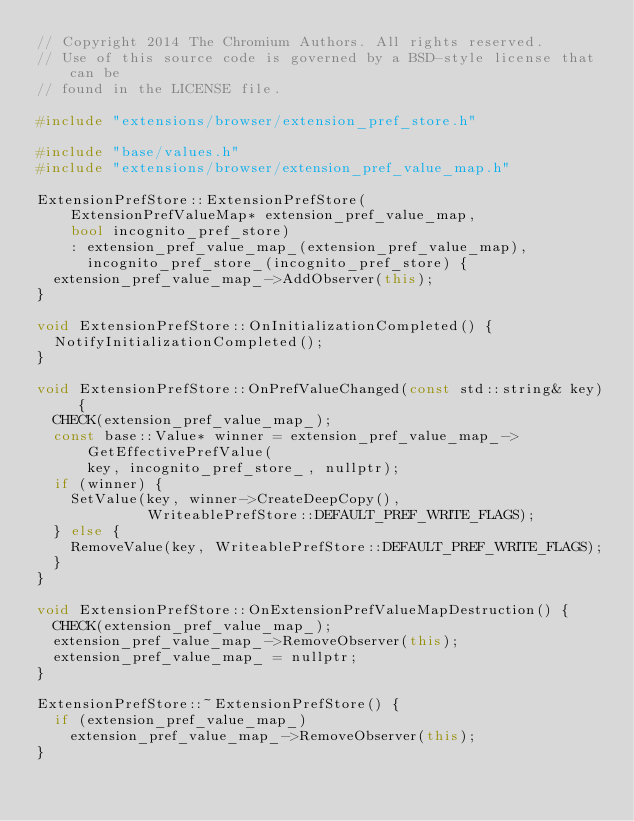<code> <loc_0><loc_0><loc_500><loc_500><_C++_>// Copyright 2014 The Chromium Authors. All rights reserved.
// Use of this source code is governed by a BSD-style license that can be
// found in the LICENSE file.

#include "extensions/browser/extension_pref_store.h"

#include "base/values.h"
#include "extensions/browser/extension_pref_value_map.h"

ExtensionPrefStore::ExtensionPrefStore(
    ExtensionPrefValueMap* extension_pref_value_map,
    bool incognito_pref_store)
    : extension_pref_value_map_(extension_pref_value_map),
      incognito_pref_store_(incognito_pref_store) {
  extension_pref_value_map_->AddObserver(this);
}

void ExtensionPrefStore::OnInitializationCompleted() {
  NotifyInitializationCompleted();
}

void ExtensionPrefStore::OnPrefValueChanged(const std::string& key) {
  CHECK(extension_pref_value_map_);
  const base::Value* winner = extension_pref_value_map_->GetEffectivePrefValue(
      key, incognito_pref_store_, nullptr);
  if (winner) {
    SetValue(key, winner->CreateDeepCopy(),
             WriteablePrefStore::DEFAULT_PREF_WRITE_FLAGS);
  } else {
    RemoveValue(key, WriteablePrefStore::DEFAULT_PREF_WRITE_FLAGS);
  }
}

void ExtensionPrefStore::OnExtensionPrefValueMapDestruction() {
  CHECK(extension_pref_value_map_);
  extension_pref_value_map_->RemoveObserver(this);
  extension_pref_value_map_ = nullptr;
}

ExtensionPrefStore::~ExtensionPrefStore() {
  if (extension_pref_value_map_)
    extension_pref_value_map_->RemoveObserver(this);
}
</code> 